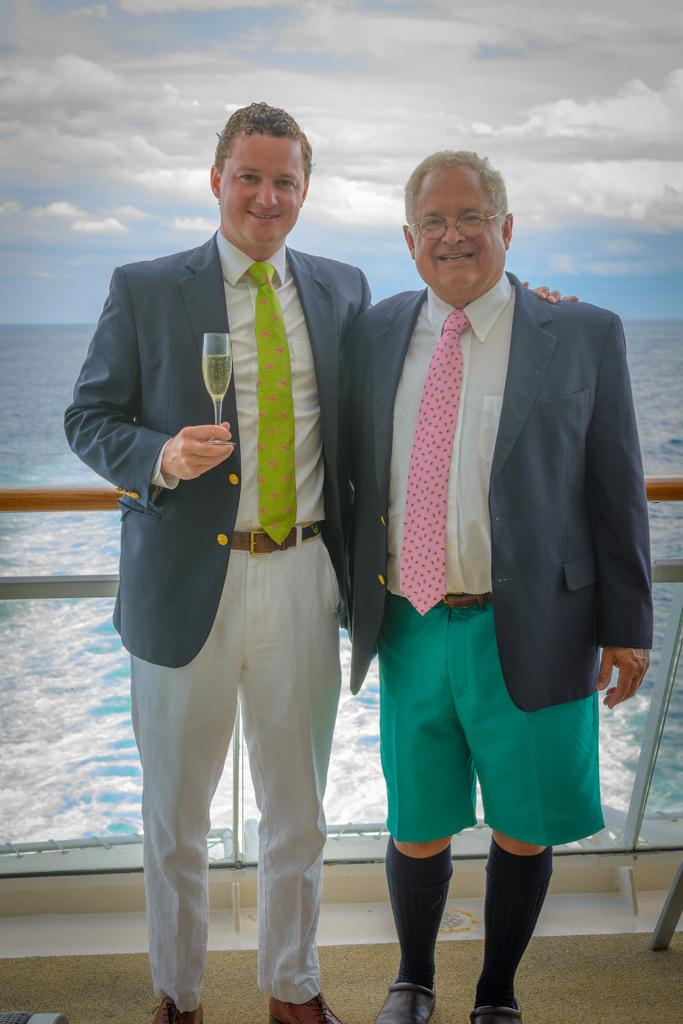What object can be seen in the image that is typically used for holding liquids? There is a glass in the image that is typically used for holding liquids. Who or what is present in the image? There are people in the image. What feature can be seen in the image that might be used for support or safety? There is a railing in the image that might be used for support or safety. What natural element is visible in the image? There is water visible in the image. What can be seen in the background of the image? There are clouds in the background of the image. Reasoning: Let' the water. We start by identifying the main objects and subjects in the image based on the provided facts. We then formulate questions that focus on the location and characteristics of these subjects and objects, ensuring that each question can be answered definitively with the information given. We avoid yes/no questions and ensure that the language is simple and clear. Absurd Question/Answer: What type of guitar is being played by the people in the image? There is no guitar present in the image; it features a glass, people, a railing, water, and clouds. What is the general feeling or emotion of the people in the image? The image does not convey any specific feelings or emotions of the people; it only shows their presence and the objects around them. What type of market is visible in the image? There is no market present in the image; it features a glass, people, a railing, water, and clouds. 